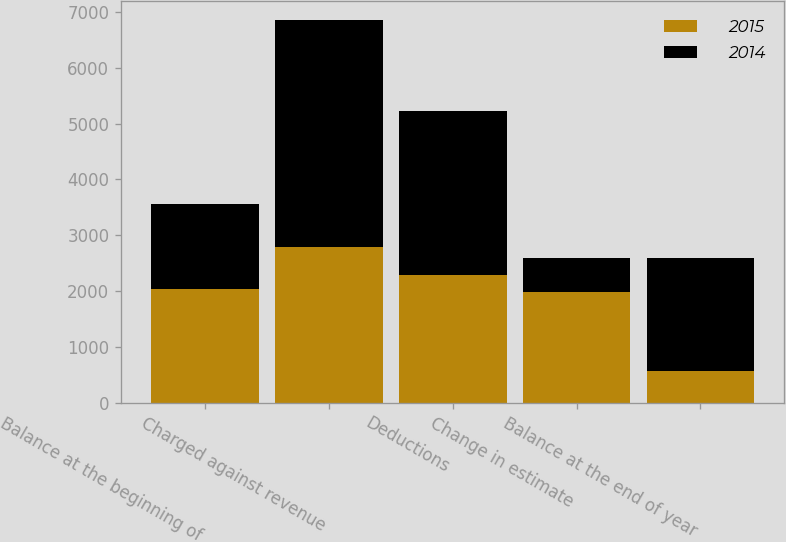<chart> <loc_0><loc_0><loc_500><loc_500><stacked_bar_chart><ecel><fcel>Balance at the beginning of<fcel>Charged against revenue<fcel>Deductions<fcel>Change in estimate<fcel>Balance at the end of year<nl><fcel>2015<fcel>2031<fcel>2798<fcel>2283<fcel>1980<fcel>566<nl><fcel>2014<fcel>1529<fcel>4063<fcel>2943<fcel>618<fcel>2031<nl></chart> 